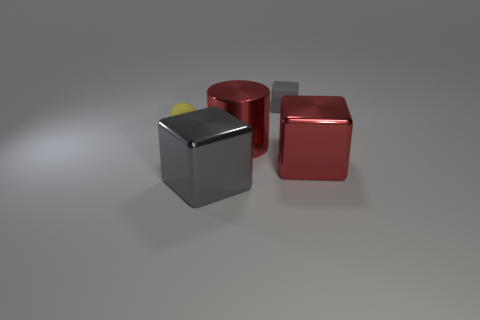Add 2 gray cylinders. How many objects exist? 7 Subtract all spheres. How many objects are left? 4 Add 1 small matte balls. How many small matte balls exist? 2 Subtract 0 cyan cubes. How many objects are left? 5 Subtract all big green metallic things. Subtract all rubber balls. How many objects are left? 4 Add 2 gray rubber things. How many gray rubber things are left? 3 